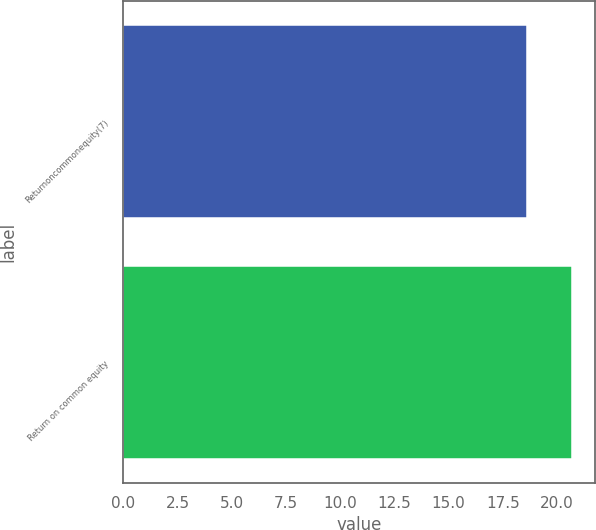Convert chart. <chart><loc_0><loc_0><loc_500><loc_500><bar_chart><fcel>Returnoncommonequity(7)<fcel>Return on common equity<nl><fcel>18.6<fcel>20.7<nl></chart> 